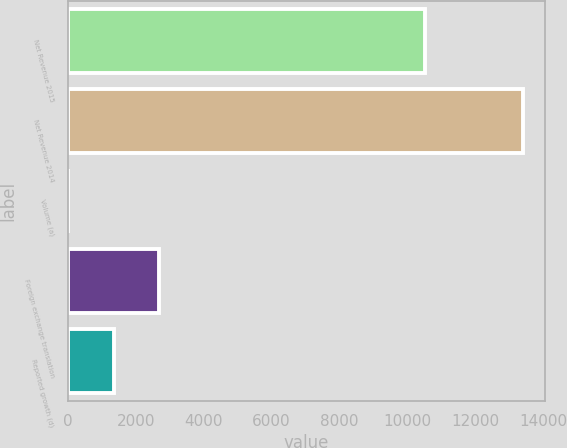Convert chart. <chart><loc_0><loc_0><loc_500><loc_500><bar_chart><fcel>Net Revenue 2015<fcel>Net Revenue 2014<fcel>Volume (a)<fcel>Foreign exchange translation<fcel>Reported growth (d)<nl><fcel>10510<fcel>13399<fcel>2<fcel>2681.4<fcel>1341.7<nl></chart> 